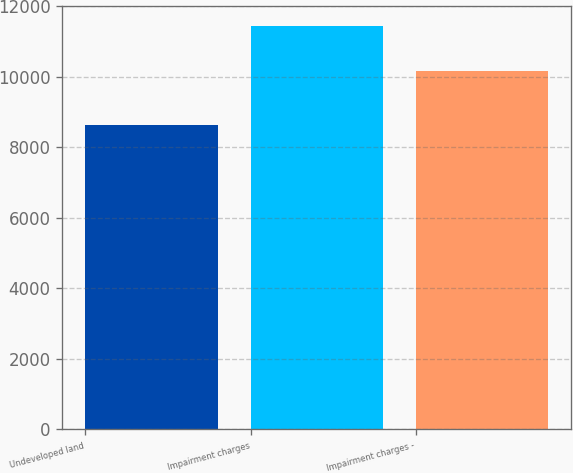Convert chart to OTSL. <chart><loc_0><loc_0><loc_500><loc_500><bar_chart><fcel>Undeveloped land<fcel>Impairment charges<fcel>Impairment charges -<nl><fcel>8632<fcel>11431<fcel>10165<nl></chart> 